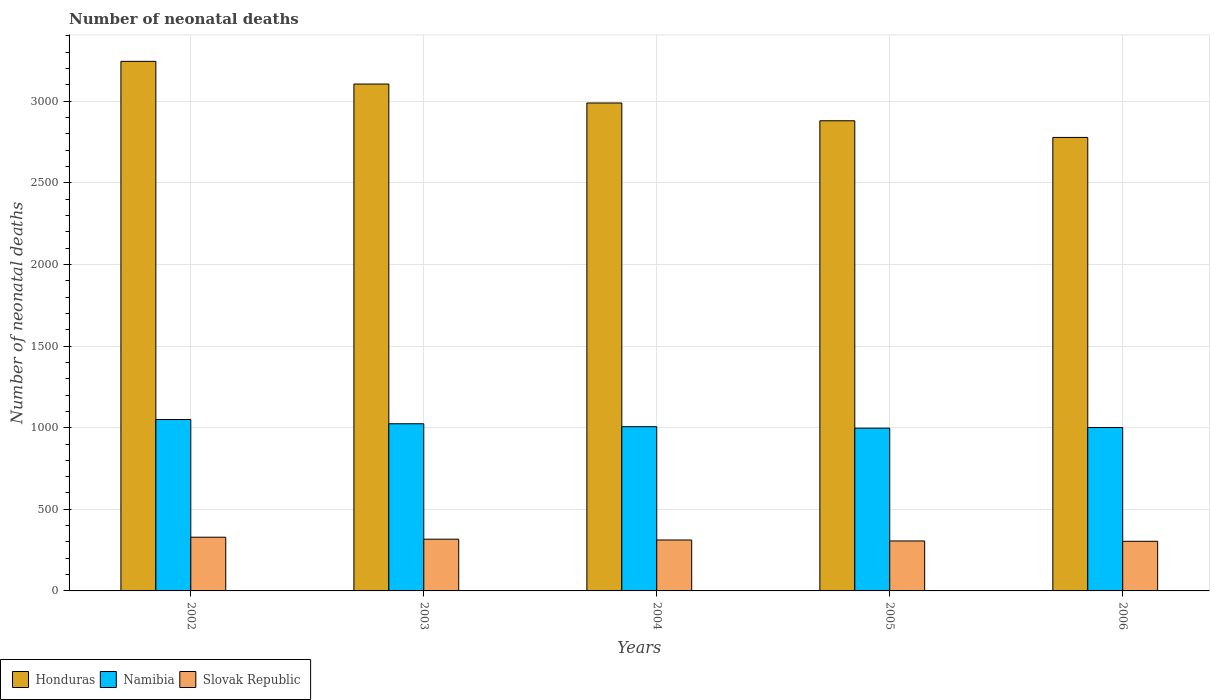How many groups of bars are there?
Offer a very short reply. 5. Are the number of bars per tick equal to the number of legend labels?
Offer a very short reply. Yes. How many bars are there on the 2nd tick from the left?
Ensure brevity in your answer.  3. What is the label of the 5th group of bars from the left?
Keep it short and to the point. 2006. What is the number of neonatal deaths in in Slovak Republic in 2003?
Provide a short and direct response. 317. Across all years, what is the maximum number of neonatal deaths in in Honduras?
Ensure brevity in your answer.  3244. Across all years, what is the minimum number of neonatal deaths in in Namibia?
Offer a terse response. 997. In which year was the number of neonatal deaths in in Namibia minimum?
Give a very brief answer. 2005. What is the total number of neonatal deaths in in Honduras in the graph?
Keep it short and to the point. 1.50e+04. What is the difference between the number of neonatal deaths in in Slovak Republic in 2002 and that in 2005?
Offer a terse response. 23. What is the difference between the number of neonatal deaths in in Namibia in 2003 and the number of neonatal deaths in in Slovak Republic in 2006?
Offer a very short reply. 720. What is the average number of neonatal deaths in in Honduras per year?
Make the answer very short. 2999.2. In the year 2004, what is the difference between the number of neonatal deaths in in Namibia and number of neonatal deaths in in Honduras?
Your answer should be compact. -1983. What is the ratio of the number of neonatal deaths in in Honduras in 2003 to that in 2006?
Ensure brevity in your answer.  1.12. Is the number of neonatal deaths in in Namibia in 2003 less than that in 2005?
Keep it short and to the point. No. Is the difference between the number of neonatal deaths in in Namibia in 2003 and 2005 greater than the difference between the number of neonatal deaths in in Honduras in 2003 and 2005?
Keep it short and to the point. No. What is the difference between the highest and the second highest number of neonatal deaths in in Honduras?
Provide a short and direct response. 139. What is the difference between the highest and the lowest number of neonatal deaths in in Honduras?
Offer a terse response. 466. Is the sum of the number of neonatal deaths in in Namibia in 2002 and 2005 greater than the maximum number of neonatal deaths in in Honduras across all years?
Provide a short and direct response. No. What does the 2nd bar from the left in 2003 represents?
Provide a succinct answer. Namibia. What does the 2nd bar from the right in 2003 represents?
Your answer should be compact. Namibia. Are all the bars in the graph horizontal?
Ensure brevity in your answer.  No. Does the graph contain grids?
Your response must be concise. Yes. What is the title of the graph?
Your answer should be compact. Number of neonatal deaths. What is the label or title of the Y-axis?
Your response must be concise. Number of neonatal deaths. What is the Number of neonatal deaths of Honduras in 2002?
Offer a terse response. 3244. What is the Number of neonatal deaths of Namibia in 2002?
Provide a succinct answer. 1050. What is the Number of neonatal deaths of Slovak Republic in 2002?
Your response must be concise. 329. What is the Number of neonatal deaths in Honduras in 2003?
Give a very brief answer. 3105. What is the Number of neonatal deaths of Namibia in 2003?
Provide a short and direct response. 1024. What is the Number of neonatal deaths of Slovak Republic in 2003?
Make the answer very short. 317. What is the Number of neonatal deaths in Honduras in 2004?
Give a very brief answer. 2989. What is the Number of neonatal deaths in Namibia in 2004?
Your response must be concise. 1006. What is the Number of neonatal deaths in Slovak Republic in 2004?
Your answer should be very brief. 312. What is the Number of neonatal deaths in Honduras in 2005?
Offer a terse response. 2880. What is the Number of neonatal deaths of Namibia in 2005?
Give a very brief answer. 997. What is the Number of neonatal deaths in Slovak Republic in 2005?
Ensure brevity in your answer.  306. What is the Number of neonatal deaths in Honduras in 2006?
Make the answer very short. 2778. What is the Number of neonatal deaths of Namibia in 2006?
Your answer should be compact. 1001. What is the Number of neonatal deaths in Slovak Republic in 2006?
Make the answer very short. 304. Across all years, what is the maximum Number of neonatal deaths of Honduras?
Offer a terse response. 3244. Across all years, what is the maximum Number of neonatal deaths in Namibia?
Provide a short and direct response. 1050. Across all years, what is the maximum Number of neonatal deaths in Slovak Republic?
Ensure brevity in your answer.  329. Across all years, what is the minimum Number of neonatal deaths of Honduras?
Offer a very short reply. 2778. Across all years, what is the minimum Number of neonatal deaths of Namibia?
Keep it short and to the point. 997. Across all years, what is the minimum Number of neonatal deaths of Slovak Republic?
Offer a terse response. 304. What is the total Number of neonatal deaths in Honduras in the graph?
Your response must be concise. 1.50e+04. What is the total Number of neonatal deaths of Namibia in the graph?
Offer a very short reply. 5078. What is the total Number of neonatal deaths of Slovak Republic in the graph?
Your answer should be compact. 1568. What is the difference between the Number of neonatal deaths of Honduras in 2002 and that in 2003?
Ensure brevity in your answer.  139. What is the difference between the Number of neonatal deaths in Namibia in 2002 and that in 2003?
Ensure brevity in your answer.  26. What is the difference between the Number of neonatal deaths in Honduras in 2002 and that in 2004?
Give a very brief answer. 255. What is the difference between the Number of neonatal deaths in Slovak Republic in 2002 and that in 2004?
Ensure brevity in your answer.  17. What is the difference between the Number of neonatal deaths in Honduras in 2002 and that in 2005?
Keep it short and to the point. 364. What is the difference between the Number of neonatal deaths in Namibia in 2002 and that in 2005?
Keep it short and to the point. 53. What is the difference between the Number of neonatal deaths in Slovak Republic in 2002 and that in 2005?
Ensure brevity in your answer.  23. What is the difference between the Number of neonatal deaths of Honduras in 2002 and that in 2006?
Offer a terse response. 466. What is the difference between the Number of neonatal deaths in Namibia in 2002 and that in 2006?
Keep it short and to the point. 49. What is the difference between the Number of neonatal deaths in Slovak Republic in 2002 and that in 2006?
Make the answer very short. 25. What is the difference between the Number of neonatal deaths in Honduras in 2003 and that in 2004?
Make the answer very short. 116. What is the difference between the Number of neonatal deaths in Namibia in 2003 and that in 2004?
Your answer should be very brief. 18. What is the difference between the Number of neonatal deaths of Honduras in 2003 and that in 2005?
Give a very brief answer. 225. What is the difference between the Number of neonatal deaths of Namibia in 2003 and that in 2005?
Provide a succinct answer. 27. What is the difference between the Number of neonatal deaths of Slovak Republic in 2003 and that in 2005?
Offer a very short reply. 11. What is the difference between the Number of neonatal deaths of Honduras in 2003 and that in 2006?
Keep it short and to the point. 327. What is the difference between the Number of neonatal deaths in Namibia in 2003 and that in 2006?
Your response must be concise. 23. What is the difference between the Number of neonatal deaths of Slovak Republic in 2003 and that in 2006?
Give a very brief answer. 13. What is the difference between the Number of neonatal deaths of Honduras in 2004 and that in 2005?
Ensure brevity in your answer.  109. What is the difference between the Number of neonatal deaths of Slovak Republic in 2004 and that in 2005?
Ensure brevity in your answer.  6. What is the difference between the Number of neonatal deaths of Honduras in 2004 and that in 2006?
Make the answer very short. 211. What is the difference between the Number of neonatal deaths in Namibia in 2004 and that in 2006?
Give a very brief answer. 5. What is the difference between the Number of neonatal deaths in Slovak Republic in 2004 and that in 2006?
Make the answer very short. 8. What is the difference between the Number of neonatal deaths of Honduras in 2005 and that in 2006?
Offer a very short reply. 102. What is the difference between the Number of neonatal deaths of Namibia in 2005 and that in 2006?
Provide a succinct answer. -4. What is the difference between the Number of neonatal deaths in Slovak Republic in 2005 and that in 2006?
Provide a short and direct response. 2. What is the difference between the Number of neonatal deaths of Honduras in 2002 and the Number of neonatal deaths of Namibia in 2003?
Your answer should be compact. 2220. What is the difference between the Number of neonatal deaths in Honduras in 2002 and the Number of neonatal deaths in Slovak Republic in 2003?
Ensure brevity in your answer.  2927. What is the difference between the Number of neonatal deaths in Namibia in 2002 and the Number of neonatal deaths in Slovak Republic in 2003?
Offer a very short reply. 733. What is the difference between the Number of neonatal deaths of Honduras in 2002 and the Number of neonatal deaths of Namibia in 2004?
Your answer should be compact. 2238. What is the difference between the Number of neonatal deaths of Honduras in 2002 and the Number of neonatal deaths of Slovak Republic in 2004?
Make the answer very short. 2932. What is the difference between the Number of neonatal deaths in Namibia in 2002 and the Number of neonatal deaths in Slovak Republic in 2004?
Your answer should be compact. 738. What is the difference between the Number of neonatal deaths in Honduras in 2002 and the Number of neonatal deaths in Namibia in 2005?
Offer a terse response. 2247. What is the difference between the Number of neonatal deaths of Honduras in 2002 and the Number of neonatal deaths of Slovak Republic in 2005?
Offer a very short reply. 2938. What is the difference between the Number of neonatal deaths of Namibia in 2002 and the Number of neonatal deaths of Slovak Republic in 2005?
Offer a very short reply. 744. What is the difference between the Number of neonatal deaths in Honduras in 2002 and the Number of neonatal deaths in Namibia in 2006?
Ensure brevity in your answer.  2243. What is the difference between the Number of neonatal deaths in Honduras in 2002 and the Number of neonatal deaths in Slovak Republic in 2006?
Keep it short and to the point. 2940. What is the difference between the Number of neonatal deaths in Namibia in 2002 and the Number of neonatal deaths in Slovak Republic in 2006?
Give a very brief answer. 746. What is the difference between the Number of neonatal deaths in Honduras in 2003 and the Number of neonatal deaths in Namibia in 2004?
Make the answer very short. 2099. What is the difference between the Number of neonatal deaths of Honduras in 2003 and the Number of neonatal deaths of Slovak Republic in 2004?
Your response must be concise. 2793. What is the difference between the Number of neonatal deaths of Namibia in 2003 and the Number of neonatal deaths of Slovak Republic in 2004?
Provide a succinct answer. 712. What is the difference between the Number of neonatal deaths of Honduras in 2003 and the Number of neonatal deaths of Namibia in 2005?
Your response must be concise. 2108. What is the difference between the Number of neonatal deaths of Honduras in 2003 and the Number of neonatal deaths of Slovak Republic in 2005?
Make the answer very short. 2799. What is the difference between the Number of neonatal deaths of Namibia in 2003 and the Number of neonatal deaths of Slovak Republic in 2005?
Provide a succinct answer. 718. What is the difference between the Number of neonatal deaths of Honduras in 2003 and the Number of neonatal deaths of Namibia in 2006?
Your answer should be compact. 2104. What is the difference between the Number of neonatal deaths of Honduras in 2003 and the Number of neonatal deaths of Slovak Republic in 2006?
Your response must be concise. 2801. What is the difference between the Number of neonatal deaths in Namibia in 2003 and the Number of neonatal deaths in Slovak Republic in 2006?
Your response must be concise. 720. What is the difference between the Number of neonatal deaths in Honduras in 2004 and the Number of neonatal deaths in Namibia in 2005?
Keep it short and to the point. 1992. What is the difference between the Number of neonatal deaths in Honduras in 2004 and the Number of neonatal deaths in Slovak Republic in 2005?
Ensure brevity in your answer.  2683. What is the difference between the Number of neonatal deaths in Namibia in 2004 and the Number of neonatal deaths in Slovak Republic in 2005?
Make the answer very short. 700. What is the difference between the Number of neonatal deaths of Honduras in 2004 and the Number of neonatal deaths of Namibia in 2006?
Ensure brevity in your answer.  1988. What is the difference between the Number of neonatal deaths of Honduras in 2004 and the Number of neonatal deaths of Slovak Republic in 2006?
Offer a terse response. 2685. What is the difference between the Number of neonatal deaths in Namibia in 2004 and the Number of neonatal deaths in Slovak Republic in 2006?
Ensure brevity in your answer.  702. What is the difference between the Number of neonatal deaths in Honduras in 2005 and the Number of neonatal deaths in Namibia in 2006?
Offer a very short reply. 1879. What is the difference between the Number of neonatal deaths in Honduras in 2005 and the Number of neonatal deaths in Slovak Republic in 2006?
Your answer should be very brief. 2576. What is the difference between the Number of neonatal deaths in Namibia in 2005 and the Number of neonatal deaths in Slovak Republic in 2006?
Your answer should be very brief. 693. What is the average Number of neonatal deaths of Honduras per year?
Keep it short and to the point. 2999.2. What is the average Number of neonatal deaths of Namibia per year?
Make the answer very short. 1015.6. What is the average Number of neonatal deaths in Slovak Republic per year?
Provide a succinct answer. 313.6. In the year 2002, what is the difference between the Number of neonatal deaths of Honduras and Number of neonatal deaths of Namibia?
Your response must be concise. 2194. In the year 2002, what is the difference between the Number of neonatal deaths of Honduras and Number of neonatal deaths of Slovak Republic?
Ensure brevity in your answer.  2915. In the year 2002, what is the difference between the Number of neonatal deaths in Namibia and Number of neonatal deaths in Slovak Republic?
Provide a short and direct response. 721. In the year 2003, what is the difference between the Number of neonatal deaths in Honduras and Number of neonatal deaths in Namibia?
Make the answer very short. 2081. In the year 2003, what is the difference between the Number of neonatal deaths in Honduras and Number of neonatal deaths in Slovak Republic?
Keep it short and to the point. 2788. In the year 2003, what is the difference between the Number of neonatal deaths of Namibia and Number of neonatal deaths of Slovak Republic?
Ensure brevity in your answer.  707. In the year 2004, what is the difference between the Number of neonatal deaths of Honduras and Number of neonatal deaths of Namibia?
Your answer should be compact. 1983. In the year 2004, what is the difference between the Number of neonatal deaths of Honduras and Number of neonatal deaths of Slovak Republic?
Ensure brevity in your answer.  2677. In the year 2004, what is the difference between the Number of neonatal deaths in Namibia and Number of neonatal deaths in Slovak Republic?
Your answer should be very brief. 694. In the year 2005, what is the difference between the Number of neonatal deaths of Honduras and Number of neonatal deaths of Namibia?
Keep it short and to the point. 1883. In the year 2005, what is the difference between the Number of neonatal deaths in Honduras and Number of neonatal deaths in Slovak Republic?
Your answer should be very brief. 2574. In the year 2005, what is the difference between the Number of neonatal deaths of Namibia and Number of neonatal deaths of Slovak Republic?
Give a very brief answer. 691. In the year 2006, what is the difference between the Number of neonatal deaths in Honduras and Number of neonatal deaths in Namibia?
Provide a short and direct response. 1777. In the year 2006, what is the difference between the Number of neonatal deaths in Honduras and Number of neonatal deaths in Slovak Republic?
Provide a short and direct response. 2474. In the year 2006, what is the difference between the Number of neonatal deaths in Namibia and Number of neonatal deaths in Slovak Republic?
Offer a terse response. 697. What is the ratio of the Number of neonatal deaths in Honduras in 2002 to that in 2003?
Provide a succinct answer. 1.04. What is the ratio of the Number of neonatal deaths of Namibia in 2002 to that in 2003?
Keep it short and to the point. 1.03. What is the ratio of the Number of neonatal deaths of Slovak Republic in 2002 to that in 2003?
Your response must be concise. 1.04. What is the ratio of the Number of neonatal deaths of Honduras in 2002 to that in 2004?
Provide a short and direct response. 1.09. What is the ratio of the Number of neonatal deaths of Namibia in 2002 to that in 2004?
Offer a very short reply. 1.04. What is the ratio of the Number of neonatal deaths in Slovak Republic in 2002 to that in 2004?
Offer a terse response. 1.05. What is the ratio of the Number of neonatal deaths of Honduras in 2002 to that in 2005?
Give a very brief answer. 1.13. What is the ratio of the Number of neonatal deaths in Namibia in 2002 to that in 2005?
Offer a very short reply. 1.05. What is the ratio of the Number of neonatal deaths in Slovak Republic in 2002 to that in 2005?
Your answer should be compact. 1.08. What is the ratio of the Number of neonatal deaths of Honduras in 2002 to that in 2006?
Make the answer very short. 1.17. What is the ratio of the Number of neonatal deaths of Namibia in 2002 to that in 2006?
Your answer should be very brief. 1.05. What is the ratio of the Number of neonatal deaths of Slovak Republic in 2002 to that in 2006?
Provide a short and direct response. 1.08. What is the ratio of the Number of neonatal deaths in Honduras in 2003 to that in 2004?
Your response must be concise. 1.04. What is the ratio of the Number of neonatal deaths in Namibia in 2003 to that in 2004?
Give a very brief answer. 1.02. What is the ratio of the Number of neonatal deaths in Honduras in 2003 to that in 2005?
Keep it short and to the point. 1.08. What is the ratio of the Number of neonatal deaths in Namibia in 2003 to that in 2005?
Your answer should be compact. 1.03. What is the ratio of the Number of neonatal deaths of Slovak Republic in 2003 to that in 2005?
Give a very brief answer. 1.04. What is the ratio of the Number of neonatal deaths of Honduras in 2003 to that in 2006?
Your answer should be compact. 1.12. What is the ratio of the Number of neonatal deaths in Slovak Republic in 2003 to that in 2006?
Provide a succinct answer. 1.04. What is the ratio of the Number of neonatal deaths of Honduras in 2004 to that in 2005?
Provide a succinct answer. 1.04. What is the ratio of the Number of neonatal deaths in Namibia in 2004 to that in 2005?
Provide a short and direct response. 1.01. What is the ratio of the Number of neonatal deaths in Slovak Republic in 2004 to that in 2005?
Provide a short and direct response. 1.02. What is the ratio of the Number of neonatal deaths in Honduras in 2004 to that in 2006?
Your answer should be compact. 1.08. What is the ratio of the Number of neonatal deaths of Namibia in 2004 to that in 2006?
Your response must be concise. 1. What is the ratio of the Number of neonatal deaths in Slovak Republic in 2004 to that in 2006?
Keep it short and to the point. 1.03. What is the ratio of the Number of neonatal deaths in Honduras in 2005 to that in 2006?
Offer a terse response. 1.04. What is the ratio of the Number of neonatal deaths of Slovak Republic in 2005 to that in 2006?
Ensure brevity in your answer.  1.01. What is the difference between the highest and the second highest Number of neonatal deaths of Honduras?
Offer a terse response. 139. What is the difference between the highest and the second highest Number of neonatal deaths of Namibia?
Ensure brevity in your answer.  26. What is the difference between the highest and the lowest Number of neonatal deaths in Honduras?
Provide a succinct answer. 466. What is the difference between the highest and the lowest Number of neonatal deaths in Slovak Republic?
Keep it short and to the point. 25. 